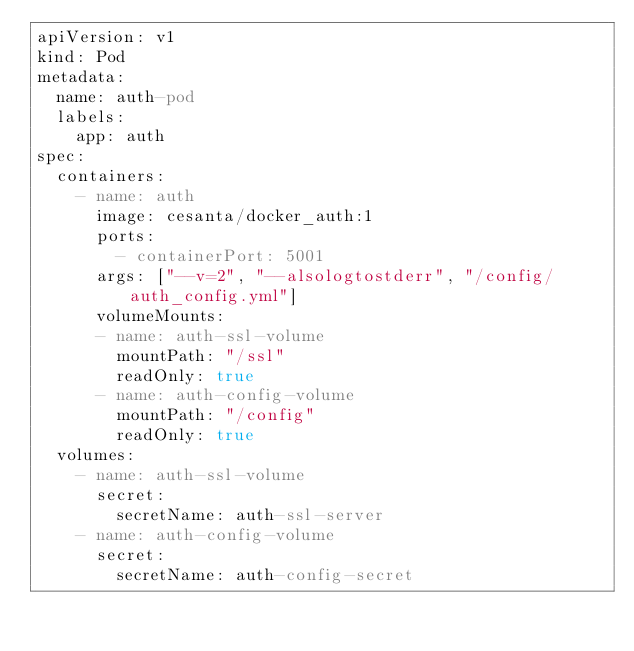Convert code to text. <code><loc_0><loc_0><loc_500><loc_500><_YAML_>apiVersion: v1
kind: Pod
metadata:
  name: auth-pod
  labels:
    app: auth
spec:
  containers:
    - name: auth
      image: cesanta/docker_auth:1
      ports:
        - containerPort: 5001
      args: ["--v=2", "--alsologtostderr", "/config/auth_config.yml"]
      volumeMounts:
      - name: auth-ssl-volume
        mountPath: "/ssl"
        readOnly: true
      - name: auth-config-volume
        mountPath: "/config"
        readOnly: true
  volumes:
    - name: auth-ssl-volume
      secret:
        secretName: auth-ssl-server
    - name: auth-config-volume
      secret:
        secretName: auth-config-secret
        

  </code> 